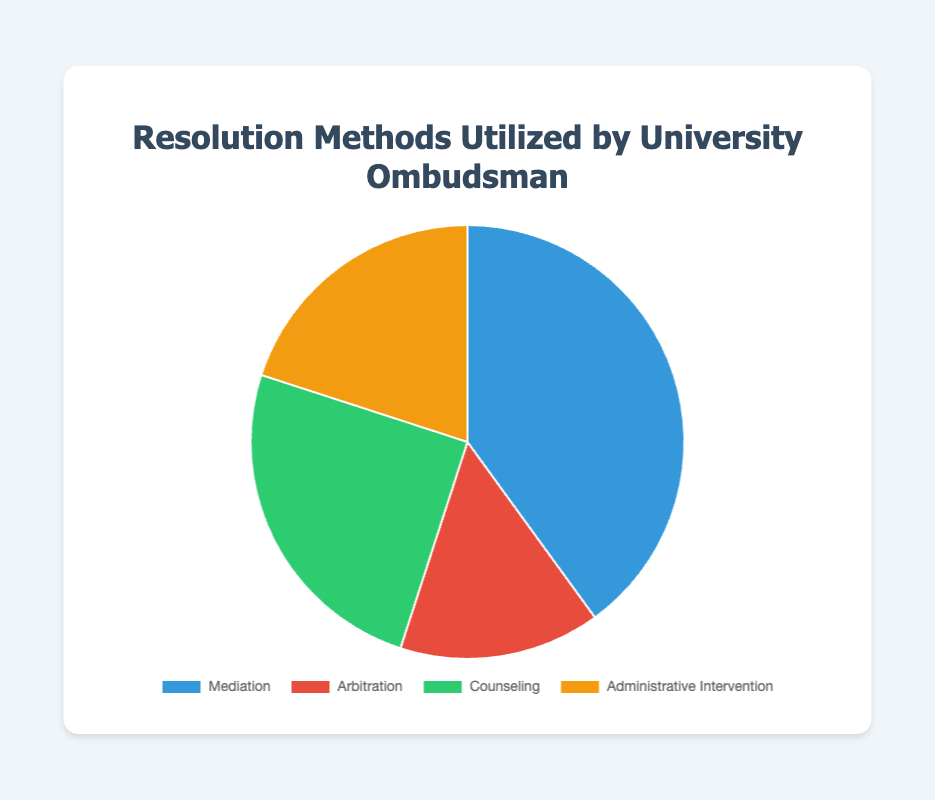What is the most utilized resolution method by the University Ombudsman? By looking at the figure, identify the largest section of the pie chart, which corresponds to the method with the highest percentage. In this case, it's Mediation with 40%.
Answer: Mediation Which resolution method is used the least according to the pie chart? Locate the smallest segment of the pie chart, which represents the method with the lowest percentage. Here, it's Arbitration with 15%.
Answer: Arbitration How much greater is the percentage of Mediation compared to Counseling? Identify the percentages for both Mediation and Counseling (40% and 25%, respectively) and subtract the smaller value from the larger one: 40% - 25% = 15%.
Answer: 15% What is the combined percentage of Counseling and Administrative Intervention? Add the percentages of Counseling and Administrative Intervention: 25% + 20% = 45%.
Answer: 45% Which two resolution methods have the closest utilization percentages? Compare the percentages: Mediation (40%), Arbitration (15%), Counseling (25%), and Administrative Intervention (20%). The closest values are Counseling (25%) and Administrative Intervention (20%), with a difference of 5%.
Answer: Counseling and Administrative Intervention What color represents Administrative Intervention in the pie chart? Observe the color corresponding to the segment labeled "Administrative Intervention." It is shown in yellow.
Answer: Yellow How does the percentage of Mediation compare to the combined percentage of Arbitration and Administrative Intervention? Mediation is 40%. The combined percentage of Arbitration and Administrative Intervention is 15% + 20% = 35%. Therefore, Mediation is 5% higher.
Answer: 5% higher If the percentages are rearranged in descending order, what is the second most utilized method? Order the percentages: Mediation (40%), Counseling (25%), Administrative Intervention (20%), and Arbitration (15%). The second highest is Counseling at 25%.
Answer: Counseling What percentage more is Mediation utilized compared to Arbitration? Subtract the percentage of Arbitration from Mediation: 40% - 15% = 25%.
Answer: 25% What fraction of the total does Counseling represent? Convert the percentage of Counseling to a fraction of the total 100%: 25% = 25/100 = 1/4.
Answer: 1/4 